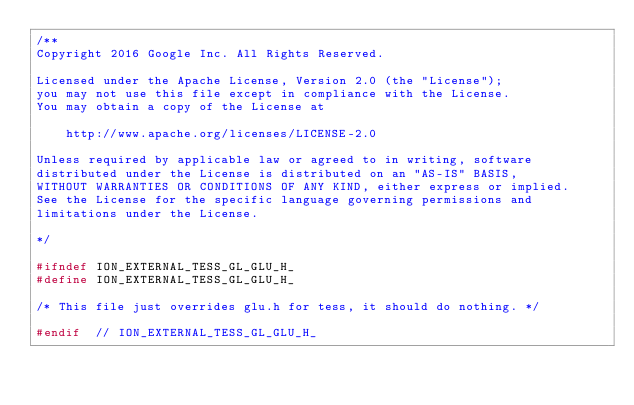Convert code to text. <code><loc_0><loc_0><loc_500><loc_500><_C_>/**
Copyright 2016 Google Inc. All Rights Reserved.

Licensed under the Apache License, Version 2.0 (the "License");
you may not use this file except in compliance with the License.
You may obtain a copy of the License at

    http://www.apache.org/licenses/LICENSE-2.0

Unless required by applicable law or agreed to in writing, software
distributed under the License is distributed on an "AS-IS" BASIS,
WITHOUT WARRANTIES OR CONDITIONS OF ANY KIND, either express or implied.
See the License for the specific language governing permissions and
limitations under the License.

*/

#ifndef ION_EXTERNAL_TESS_GL_GLU_H_
#define ION_EXTERNAL_TESS_GL_GLU_H_

/* This file just overrides glu.h for tess, it should do nothing. */

#endif  // ION_EXTERNAL_TESS_GL_GLU_H_
</code> 